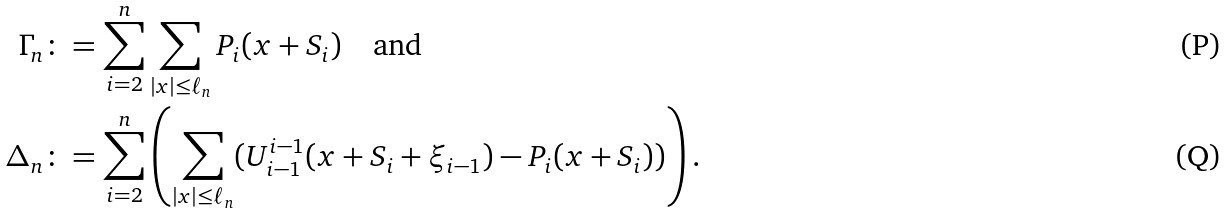Convert formula to latex. <formula><loc_0><loc_0><loc_500><loc_500>\Gamma _ { n } & \colon = \sum _ { i = 2 } ^ { n } \sum _ { | x | \leq \ell _ { n } } P _ { i } ( x + S _ { i } ) \quad \text {and} \\ \Delta _ { n } & \colon = \sum _ { i = 2 } ^ { n } \left ( \sum _ { | x | \leq \ell _ { n } } ( U ^ { i - 1 } _ { i - 1 } ( x + S _ { i } + \xi _ { i - 1 } ) - P _ { i } ( x + S _ { i } ) ) \right ) .</formula> 